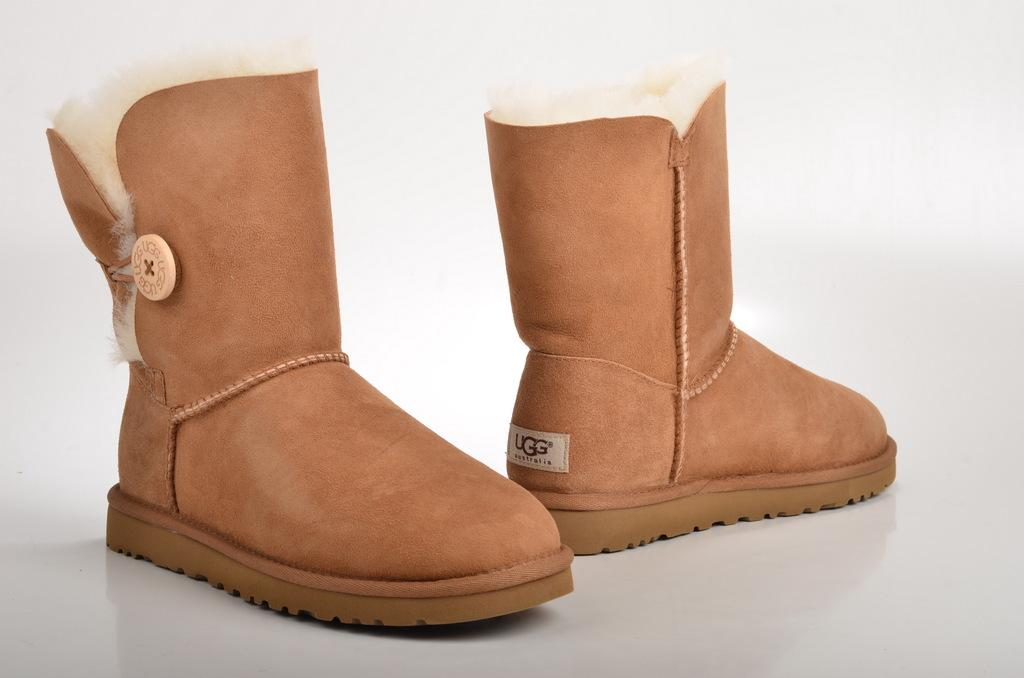What objects are present in the image? There are shoes in the image. What is the color of the surface on which the shoes are placed? The shoes are on a white surface. What type of shock can be seen coming from the shoes in the image? There is no shock present in the image; it only features shoes on a white surface. 